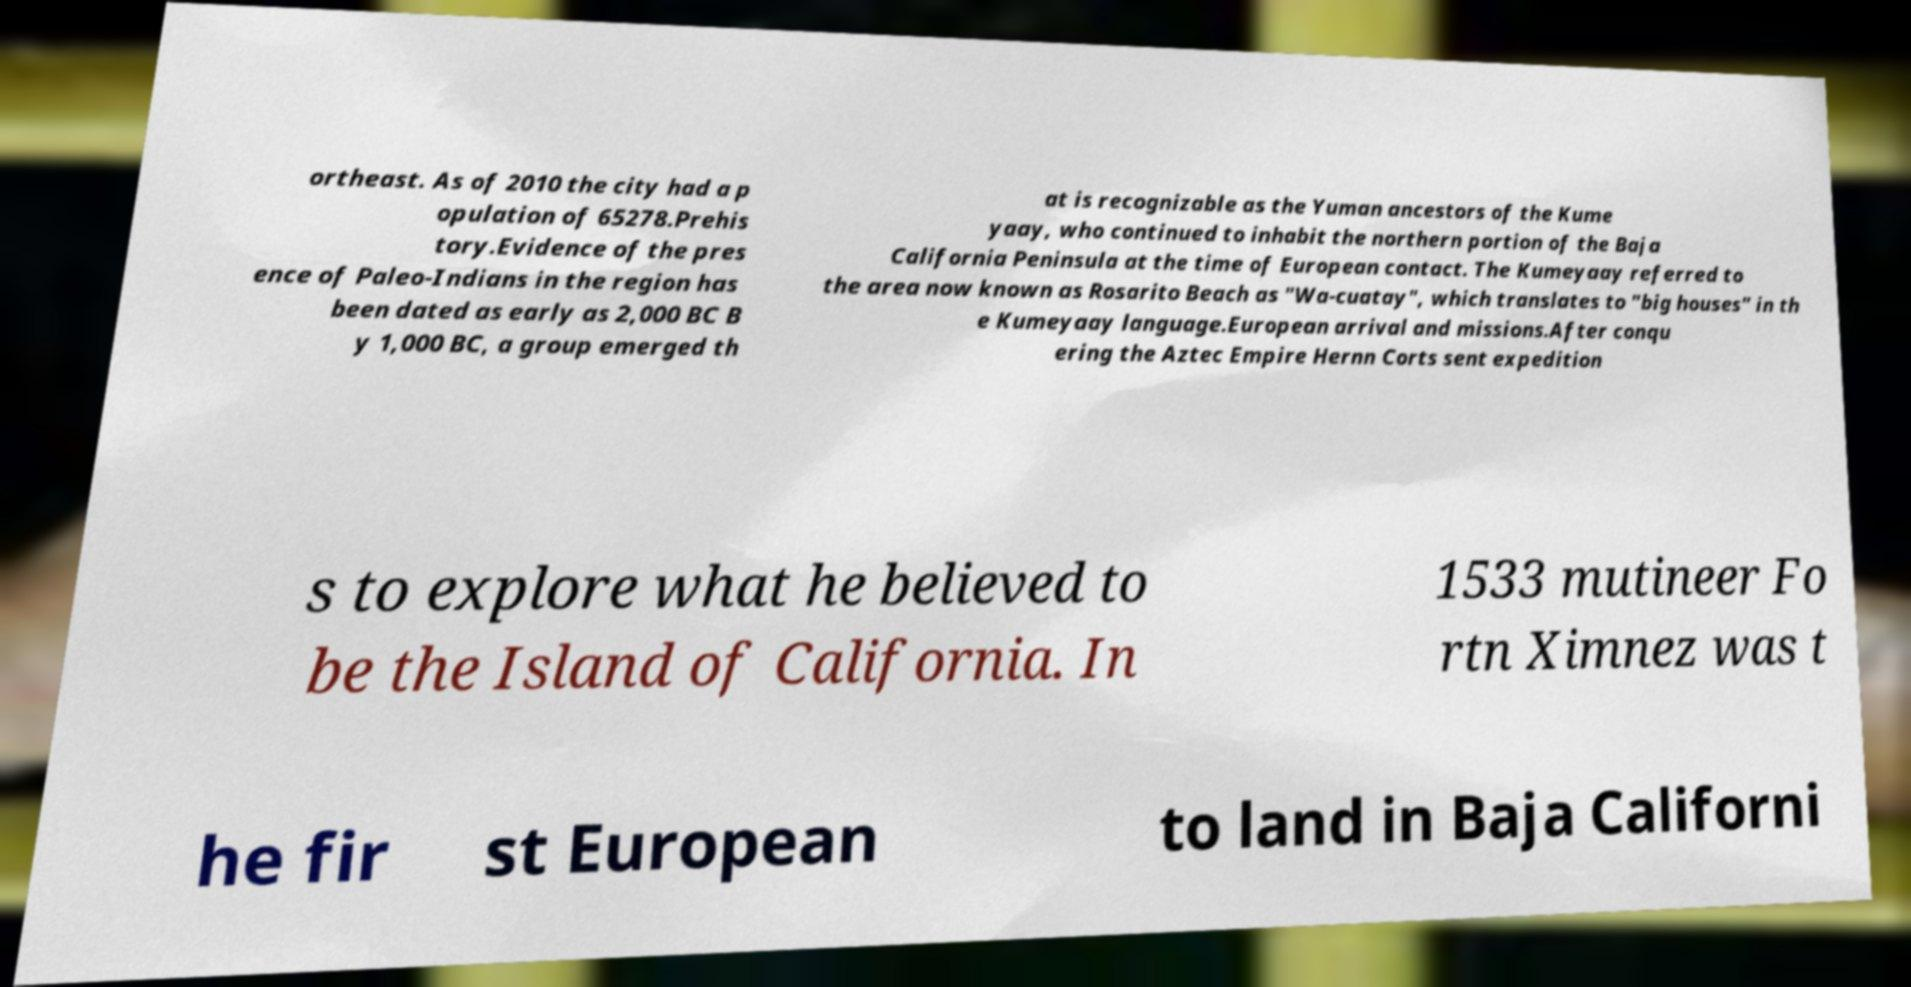Please read and relay the text visible in this image. What does it say? ortheast. As of 2010 the city had a p opulation of 65278.Prehis tory.Evidence of the pres ence of Paleo-Indians in the region has been dated as early as 2,000 BC B y 1,000 BC, a group emerged th at is recognizable as the Yuman ancestors of the Kume yaay, who continued to inhabit the northern portion of the Baja California Peninsula at the time of European contact. The Kumeyaay referred to the area now known as Rosarito Beach as "Wa-cuatay", which translates to "big houses" in th e Kumeyaay language.European arrival and missions.After conqu ering the Aztec Empire Hernn Corts sent expedition s to explore what he believed to be the Island of California. In 1533 mutineer Fo rtn Ximnez was t he fir st European to land in Baja Californi 